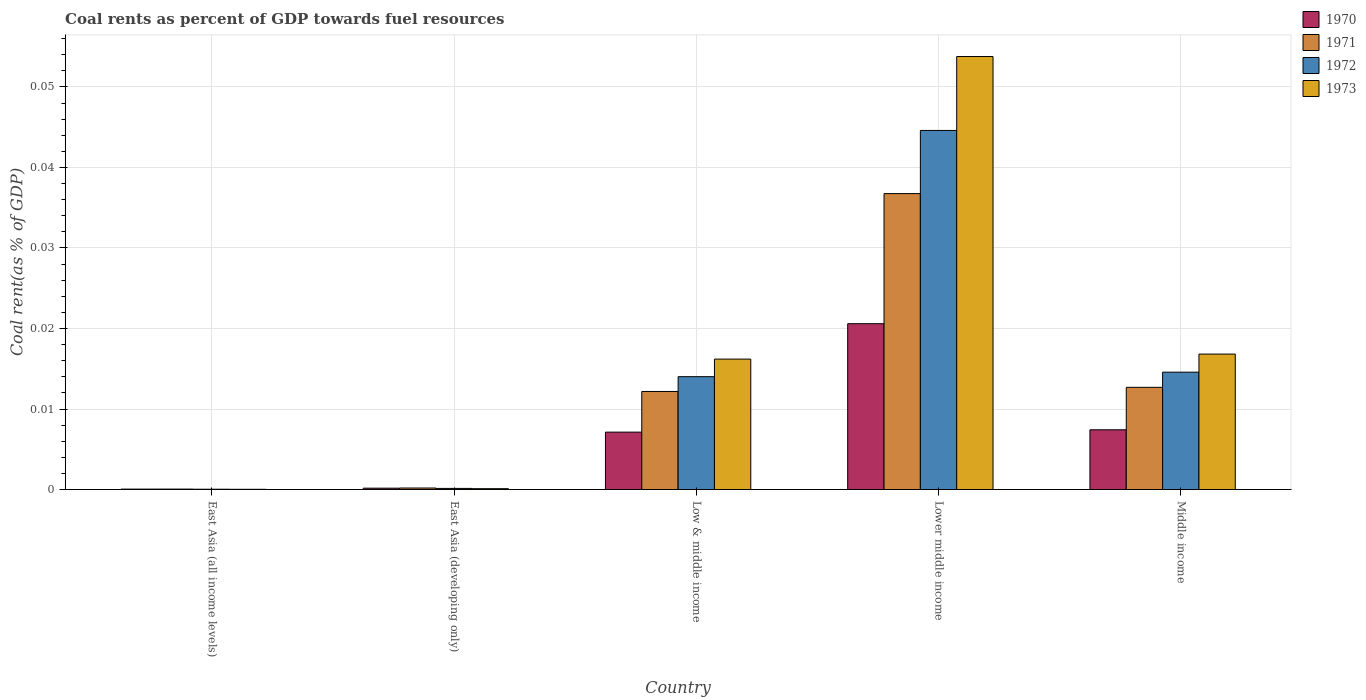Are the number of bars per tick equal to the number of legend labels?
Provide a succinct answer. Yes. Are the number of bars on each tick of the X-axis equal?
Offer a very short reply. Yes. What is the label of the 3rd group of bars from the left?
Provide a succinct answer. Low & middle income. What is the coal rent in 1973 in Middle income?
Provide a short and direct response. 0.02. Across all countries, what is the maximum coal rent in 1970?
Your response must be concise. 0.02. Across all countries, what is the minimum coal rent in 1972?
Give a very brief answer. 3.67730514806032e-5. In which country was the coal rent in 1970 maximum?
Ensure brevity in your answer.  Lower middle income. In which country was the coal rent in 1972 minimum?
Give a very brief answer. East Asia (all income levels). What is the total coal rent in 1973 in the graph?
Give a very brief answer. 0.09. What is the difference between the coal rent in 1973 in East Asia (all income levels) and that in Lower middle income?
Your answer should be very brief. -0.05. What is the difference between the coal rent in 1970 in Low & middle income and the coal rent in 1971 in East Asia (developing only)?
Offer a very short reply. 0.01. What is the average coal rent in 1972 per country?
Provide a short and direct response. 0.01. What is the difference between the coal rent of/in 1970 and coal rent of/in 1973 in Lower middle income?
Provide a succinct answer. -0.03. In how many countries, is the coal rent in 1971 greater than 0.05 %?
Ensure brevity in your answer.  0. What is the ratio of the coal rent in 1973 in Low & middle income to that in Lower middle income?
Offer a very short reply. 0.3. What is the difference between the highest and the second highest coal rent in 1970?
Offer a very short reply. 0.01. What is the difference between the highest and the lowest coal rent in 1972?
Provide a succinct answer. 0.04. Is the sum of the coal rent in 1970 in East Asia (all income levels) and Low & middle income greater than the maximum coal rent in 1971 across all countries?
Ensure brevity in your answer.  No. Is it the case that in every country, the sum of the coal rent in 1971 and coal rent in 1973 is greater than the sum of coal rent in 1970 and coal rent in 1972?
Your answer should be very brief. No. What does the 3rd bar from the left in Lower middle income represents?
Ensure brevity in your answer.  1972. Are all the bars in the graph horizontal?
Give a very brief answer. No. How many countries are there in the graph?
Keep it short and to the point. 5. Does the graph contain grids?
Your answer should be very brief. Yes. How many legend labels are there?
Make the answer very short. 4. What is the title of the graph?
Make the answer very short. Coal rents as percent of GDP towards fuel resources. What is the label or title of the Y-axis?
Your answer should be very brief. Coal rent(as % of GDP). What is the Coal rent(as % of GDP) of 1970 in East Asia (all income levels)?
Keep it short and to the point. 5.1314079013758e-5. What is the Coal rent(as % of GDP) in 1971 in East Asia (all income levels)?
Your answer should be very brief. 5.470114168356261e-5. What is the Coal rent(as % of GDP) in 1972 in East Asia (all income levels)?
Keep it short and to the point. 3.67730514806032e-5. What is the Coal rent(as % of GDP) in 1973 in East Asia (all income levels)?
Ensure brevity in your answer.  2.64171247686014e-5. What is the Coal rent(as % of GDP) in 1970 in East Asia (developing only)?
Make the answer very short. 0. What is the Coal rent(as % of GDP) in 1971 in East Asia (developing only)?
Offer a very short reply. 0. What is the Coal rent(as % of GDP) of 1972 in East Asia (developing only)?
Ensure brevity in your answer.  0. What is the Coal rent(as % of GDP) in 1973 in East Asia (developing only)?
Your answer should be very brief. 0. What is the Coal rent(as % of GDP) of 1970 in Low & middle income?
Offer a very short reply. 0.01. What is the Coal rent(as % of GDP) of 1971 in Low & middle income?
Offer a very short reply. 0.01. What is the Coal rent(as % of GDP) in 1972 in Low & middle income?
Keep it short and to the point. 0.01. What is the Coal rent(as % of GDP) of 1973 in Low & middle income?
Your answer should be compact. 0.02. What is the Coal rent(as % of GDP) of 1970 in Lower middle income?
Give a very brief answer. 0.02. What is the Coal rent(as % of GDP) of 1971 in Lower middle income?
Give a very brief answer. 0.04. What is the Coal rent(as % of GDP) of 1972 in Lower middle income?
Keep it short and to the point. 0.04. What is the Coal rent(as % of GDP) in 1973 in Lower middle income?
Give a very brief answer. 0.05. What is the Coal rent(as % of GDP) of 1970 in Middle income?
Keep it short and to the point. 0.01. What is the Coal rent(as % of GDP) of 1971 in Middle income?
Your answer should be compact. 0.01. What is the Coal rent(as % of GDP) of 1972 in Middle income?
Your answer should be very brief. 0.01. What is the Coal rent(as % of GDP) of 1973 in Middle income?
Offer a terse response. 0.02. Across all countries, what is the maximum Coal rent(as % of GDP) in 1970?
Offer a terse response. 0.02. Across all countries, what is the maximum Coal rent(as % of GDP) in 1971?
Make the answer very short. 0.04. Across all countries, what is the maximum Coal rent(as % of GDP) of 1972?
Your response must be concise. 0.04. Across all countries, what is the maximum Coal rent(as % of GDP) in 1973?
Provide a succinct answer. 0.05. Across all countries, what is the minimum Coal rent(as % of GDP) in 1970?
Ensure brevity in your answer.  5.1314079013758e-5. Across all countries, what is the minimum Coal rent(as % of GDP) of 1971?
Keep it short and to the point. 5.470114168356261e-5. Across all countries, what is the minimum Coal rent(as % of GDP) of 1972?
Your answer should be compact. 3.67730514806032e-5. Across all countries, what is the minimum Coal rent(as % of GDP) in 1973?
Offer a very short reply. 2.64171247686014e-5. What is the total Coal rent(as % of GDP) in 1970 in the graph?
Ensure brevity in your answer.  0.04. What is the total Coal rent(as % of GDP) in 1971 in the graph?
Give a very brief answer. 0.06. What is the total Coal rent(as % of GDP) of 1972 in the graph?
Offer a very short reply. 0.07. What is the total Coal rent(as % of GDP) of 1973 in the graph?
Your answer should be compact. 0.09. What is the difference between the Coal rent(as % of GDP) in 1970 in East Asia (all income levels) and that in East Asia (developing only)?
Keep it short and to the point. -0. What is the difference between the Coal rent(as % of GDP) of 1971 in East Asia (all income levels) and that in East Asia (developing only)?
Ensure brevity in your answer.  -0. What is the difference between the Coal rent(as % of GDP) of 1972 in East Asia (all income levels) and that in East Asia (developing only)?
Your response must be concise. -0. What is the difference between the Coal rent(as % of GDP) in 1973 in East Asia (all income levels) and that in East Asia (developing only)?
Offer a terse response. -0. What is the difference between the Coal rent(as % of GDP) of 1970 in East Asia (all income levels) and that in Low & middle income?
Keep it short and to the point. -0.01. What is the difference between the Coal rent(as % of GDP) in 1971 in East Asia (all income levels) and that in Low & middle income?
Provide a succinct answer. -0.01. What is the difference between the Coal rent(as % of GDP) in 1972 in East Asia (all income levels) and that in Low & middle income?
Your answer should be compact. -0.01. What is the difference between the Coal rent(as % of GDP) of 1973 in East Asia (all income levels) and that in Low & middle income?
Ensure brevity in your answer.  -0.02. What is the difference between the Coal rent(as % of GDP) of 1970 in East Asia (all income levels) and that in Lower middle income?
Your answer should be very brief. -0.02. What is the difference between the Coal rent(as % of GDP) of 1971 in East Asia (all income levels) and that in Lower middle income?
Provide a succinct answer. -0.04. What is the difference between the Coal rent(as % of GDP) in 1972 in East Asia (all income levels) and that in Lower middle income?
Give a very brief answer. -0.04. What is the difference between the Coal rent(as % of GDP) of 1973 in East Asia (all income levels) and that in Lower middle income?
Your response must be concise. -0.05. What is the difference between the Coal rent(as % of GDP) in 1970 in East Asia (all income levels) and that in Middle income?
Provide a succinct answer. -0.01. What is the difference between the Coal rent(as % of GDP) in 1971 in East Asia (all income levels) and that in Middle income?
Ensure brevity in your answer.  -0.01. What is the difference between the Coal rent(as % of GDP) of 1972 in East Asia (all income levels) and that in Middle income?
Keep it short and to the point. -0.01. What is the difference between the Coal rent(as % of GDP) of 1973 in East Asia (all income levels) and that in Middle income?
Provide a succinct answer. -0.02. What is the difference between the Coal rent(as % of GDP) of 1970 in East Asia (developing only) and that in Low & middle income?
Keep it short and to the point. -0.01. What is the difference between the Coal rent(as % of GDP) of 1971 in East Asia (developing only) and that in Low & middle income?
Keep it short and to the point. -0.01. What is the difference between the Coal rent(as % of GDP) of 1972 in East Asia (developing only) and that in Low & middle income?
Offer a terse response. -0.01. What is the difference between the Coal rent(as % of GDP) of 1973 in East Asia (developing only) and that in Low & middle income?
Your answer should be very brief. -0.02. What is the difference between the Coal rent(as % of GDP) in 1970 in East Asia (developing only) and that in Lower middle income?
Your answer should be compact. -0.02. What is the difference between the Coal rent(as % of GDP) in 1971 in East Asia (developing only) and that in Lower middle income?
Ensure brevity in your answer.  -0.04. What is the difference between the Coal rent(as % of GDP) of 1972 in East Asia (developing only) and that in Lower middle income?
Offer a terse response. -0.04. What is the difference between the Coal rent(as % of GDP) of 1973 in East Asia (developing only) and that in Lower middle income?
Your response must be concise. -0.05. What is the difference between the Coal rent(as % of GDP) in 1970 in East Asia (developing only) and that in Middle income?
Your answer should be compact. -0.01. What is the difference between the Coal rent(as % of GDP) of 1971 in East Asia (developing only) and that in Middle income?
Your answer should be very brief. -0.01. What is the difference between the Coal rent(as % of GDP) of 1972 in East Asia (developing only) and that in Middle income?
Offer a very short reply. -0.01. What is the difference between the Coal rent(as % of GDP) in 1973 in East Asia (developing only) and that in Middle income?
Offer a terse response. -0.02. What is the difference between the Coal rent(as % of GDP) of 1970 in Low & middle income and that in Lower middle income?
Provide a succinct answer. -0.01. What is the difference between the Coal rent(as % of GDP) in 1971 in Low & middle income and that in Lower middle income?
Provide a short and direct response. -0.02. What is the difference between the Coal rent(as % of GDP) of 1972 in Low & middle income and that in Lower middle income?
Make the answer very short. -0.03. What is the difference between the Coal rent(as % of GDP) in 1973 in Low & middle income and that in Lower middle income?
Give a very brief answer. -0.04. What is the difference between the Coal rent(as % of GDP) of 1970 in Low & middle income and that in Middle income?
Offer a very short reply. -0. What is the difference between the Coal rent(as % of GDP) of 1971 in Low & middle income and that in Middle income?
Ensure brevity in your answer.  -0. What is the difference between the Coal rent(as % of GDP) of 1972 in Low & middle income and that in Middle income?
Give a very brief answer. -0. What is the difference between the Coal rent(as % of GDP) of 1973 in Low & middle income and that in Middle income?
Your answer should be very brief. -0. What is the difference between the Coal rent(as % of GDP) of 1970 in Lower middle income and that in Middle income?
Your answer should be very brief. 0.01. What is the difference between the Coal rent(as % of GDP) in 1971 in Lower middle income and that in Middle income?
Provide a succinct answer. 0.02. What is the difference between the Coal rent(as % of GDP) of 1973 in Lower middle income and that in Middle income?
Provide a succinct answer. 0.04. What is the difference between the Coal rent(as % of GDP) in 1970 in East Asia (all income levels) and the Coal rent(as % of GDP) in 1971 in East Asia (developing only)?
Your answer should be very brief. -0. What is the difference between the Coal rent(as % of GDP) in 1970 in East Asia (all income levels) and the Coal rent(as % of GDP) in 1972 in East Asia (developing only)?
Ensure brevity in your answer.  -0. What is the difference between the Coal rent(as % of GDP) of 1970 in East Asia (all income levels) and the Coal rent(as % of GDP) of 1973 in East Asia (developing only)?
Your response must be concise. -0. What is the difference between the Coal rent(as % of GDP) of 1971 in East Asia (all income levels) and the Coal rent(as % of GDP) of 1972 in East Asia (developing only)?
Offer a very short reply. -0. What is the difference between the Coal rent(as % of GDP) in 1971 in East Asia (all income levels) and the Coal rent(as % of GDP) in 1973 in East Asia (developing only)?
Provide a succinct answer. -0. What is the difference between the Coal rent(as % of GDP) in 1972 in East Asia (all income levels) and the Coal rent(as % of GDP) in 1973 in East Asia (developing only)?
Ensure brevity in your answer.  -0. What is the difference between the Coal rent(as % of GDP) in 1970 in East Asia (all income levels) and the Coal rent(as % of GDP) in 1971 in Low & middle income?
Your response must be concise. -0.01. What is the difference between the Coal rent(as % of GDP) in 1970 in East Asia (all income levels) and the Coal rent(as % of GDP) in 1972 in Low & middle income?
Your answer should be very brief. -0.01. What is the difference between the Coal rent(as % of GDP) in 1970 in East Asia (all income levels) and the Coal rent(as % of GDP) in 1973 in Low & middle income?
Give a very brief answer. -0.02. What is the difference between the Coal rent(as % of GDP) in 1971 in East Asia (all income levels) and the Coal rent(as % of GDP) in 1972 in Low & middle income?
Your answer should be compact. -0.01. What is the difference between the Coal rent(as % of GDP) in 1971 in East Asia (all income levels) and the Coal rent(as % of GDP) in 1973 in Low & middle income?
Make the answer very short. -0.02. What is the difference between the Coal rent(as % of GDP) in 1972 in East Asia (all income levels) and the Coal rent(as % of GDP) in 1973 in Low & middle income?
Your answer should be very brief. -0.02. What is the difference between the Coal rent(as % of GDP) of 1970 in East Asia (all income levels) and the Coal rent(as % of GDP) of 1971 in Lower middle income?
Provide a succinct answer. -0.04. What is the difference between the Coal rent(as % of GDP) in 1970 in East Asia (all income levels) and the Coal rent(as % of GDP) in 1972 in Lower middle income?
Your answer should be compact. -0.04. What is the difference between the Coal rent(as % of GDP) of 1970 in East Asia (all income levels) and the Coal rent(as % of GDP) of 1973 in Lower middle income?
Give a very brief answer. -0.05. What is the difference between the Coal rent(as % of GDP) in 1971 in East Asia (all income levels) and the Coal rent(as % of GDP) in 1972 in Lower middle income?
Your answer should be compact. -0.04. What is the difference between the Coal rent(as % of GDP) in 1971 in East Asia (all income levels) and the Coal rent(as % of GDP) in 1973 in Lower middle income?
Ensure brevity in your answer.  -0.05. What is the difference between the Coal rent(as % of GDP) in 1972 in East Asia (all income levels) and the Coal rent(as % of GDP) in 1973 in Lower middle income?
Provide a short and direct response. -0.05. What is the difference between the Coal rent(as % of GDP) in 1970 in East Asia (all income levels) and the Coal rent(as % of GDP) in 1971 in Middle income?
Your response must be concise. -0.01. What is the difference between the Coal rent(as % of GDP) of 1970 in East Asia (all income levels) and the Coal rent(as % of GDP) of 1972 in Middle income?
Your response must be concise. -0.01. What is the difference between the Coal rent(as % of GDP) in 1970 in East Asia (all income levels) and the Coal rent(as % of GDP) in 1973 in Middle income?
Make the answer very short. -0.02. What is the difference between the Coal rent(as % of GDP) of 1971 in East Asia (all income levels) and the Coal rent(as % of GDP) of 1972 in Middle income?
Give a very brief answer. -0.01. What is the difference between the Coal rent(as % of GDP) in 1971 in East Asia (all income levels) and the Coal rent(as % of GDP) in 1973 in Middle income?
Ensure brevity in your answer.  -0.02. What is the difference between the Coal rent(as % of GDP) of 1972 in East Asia (all income levels) and the Coal rent(as % of GDP) of 1973 in Middle income?
Offer a terse response. -0.02. What is the difference between the Coal rent(as % of GDP) in 1970 in East Asia (developing only) and the Coal rent(as % of GDP) in 1971 in Low & middle income?
Keep it short and to the point. -0.01. What is the difference between the Coal rent(as % of GDP) of 1970 in East Asia (developing only) and the Coal rent(as % of GDP) of 1972 in Low & middle income?
Offer a terse response. -0.01. What is the difference between the Coal rent(as % of GDP) of 1970 in East Asia (developing only) and the Coal rent(as % of GDP) of 1973 in Low & middle income?
Provide a succinct answer. -0.02. What is the difference between the Coal rent(as % of GDP) of 1971 in East Asia (developing only) and the Coal rent(as % of GDP) of 1972 in Low & middle income?
Your answer should be compact. -0.01. What is the difference between the Coal rent(as % of GDP) of 1971 in East Asia (developing only) and the Coal rent(as % of GDP) of 1973 in Low & middle income?
Keep it short and to the point. -0.02. What is the difference between the Coal rent(as % of GDP) in 1972 in East Asia (developing only) and the Coal rent(as % of GDP) in 1973 in Low & middle income?
Provide a succinct answer. -0.02. What is the difference between the Coal rent(as % of GDP) in 1970 in East Asia (developing only) and the Coal rent(as % of GDP) in 1971 in Lower middle income?
Your answer should be very brief. -0.04. What is the difference between the Coal rent(as % of GDP) in 1970 in East Asia (developing only) and the Coal rent(as % of GDP) in 1972 in Lower middle income?
Provide a succinct answer. -0.04. What is the difference between the Coal rent(as % of GDP) of 1970 in East Asia (developing only) and the Coal rent(as % of GDP) of 1973 in Lower middle income?
Offer a very short reply. -0.05. What is the difference between the Coal rent(as % of GDP) of 1971 in East Asia (developing only) and the Coal rent(as % of GDP) of 1972 in Lower middle income?
Ensure brevity in your answer.  -0.04. What is the difference between the Coal rent(as % of GDP) in 1971 in East Asia (developing only) and the Coal rent(as % of GDP) in 1973 in Lower middle income?
Offer a very short reply. -0.05. What is the difference between the Coal rent(as % of GDP) in 1972 in East Asia (developing only) and the Coal rent(as % of GDP) in 1973 in Lower middle income?
Provide a short and direct response. -0.05. What is the difference between the Coal rent(as % of GDP) of 1970 in East Asia (developing only) and the Coal rent(as % of GDP) of 1971 in Middle income?
Provide a succinct answer. -0.01. What is the difference between the Coal rent(as % of GDP) of 1970 in East Asia (developing only) and the Coal rent(as % of GDP) of 1972 in Middle income?
Give a very brief answer. -0.01. What is the difference between the Coal rent(as % of GDP) in 1970 in East Asia (developing only) and the Coal rent(as % of GDP) in 1973 in Middle income?
Your answer should be very brief. -0.02. What is the difference between the Coal rent(as % of GDP) in 1971 in East Asia (developing only) and the Coal rent(as % of GDP) in 1972 in Middle income?
Offer a very short reply. -0.01. What is the difference between the Coal rent(as % of GDP) in 1971 in East Asia (developing only) and the Coal rent(as % of GDP) in 1973 in Middle income?
Offer a terse response. -0.02. What is the difference between the Coal rent(as % of GDP) of 1972 in East Asia (developing only) and the Coal rent(as % of GDP) of 1973 in Middle income?
Make the answer very short. -0.02. What is the difference between the Coal rent(as % of GDP) of 1970 in Low & middle income and the Coal rent(as % of GDP) of 1971 in Lower middle income?
Offer a terse response. -0.03. What is the difference between the Coal rent(as % of GDP) in 1970 in Low & middle income and the Coal rent(as % of GDP) in 1972 in Lower middle income?
Provide a short and direct response. -0.04. What is the difference between the Coal rent(as % of GDP) in 1970 in Low & middle income and the Coal rent(as % of GDP) in 1973 in Lower middle income?
Your response must be concise. -0.05. What is the difference between the Coal rent(as % of GDP) in 1971 in Low & middle income and the Coal rent(as % of GDP) in 1972 in Lower middle income?
Offer a terse response. -0.03. What is the difference between the Coal rent(as % of GDP) in 1971 in Low & middle income and the Coal rent(as % of GDP) in 1973 in Lower middle income?
Your response must be concise. -0.04. What is the difference between the Coal rent(as % of GDP) in 1972 in Low & middle income and the Coal rent(as % of GDP) in 1973 in Lower middle income?
Give a very brief answer. -0.04. What is the difference between the Coal rent(as % of GDP) in 1970 in Low & middle income and the Coal rent(as % of GDP) in 1971 in Middle income?
Ensure brevity in your answer.  -0.01. What is the difference between the Coal rent(as % of GDP) in 1970 in Low & middle income and the Coal rent(as % of GDP) in 1972 in Middle income?
Your answer should be very brief. -0.01. What is the difference between the Coal rent(as % of GDP) in 1970 in Low & middle income and the Coal rent(as % of GDP) in 1973 in Middle income?
Offer a terse response. -0.01. What is the difference between the Coal rent(as % of GDP) of 1971 in Low & middle income and the Coal rent(as % of GDP) of 1972 in Middle income?
Keep it short and to the point. -0. What is the difference between the Coal rent(as % of GDP) of 1971 in Low & middle income and the Coal rent(as % of GDP) of 1973 in Middle income?
Your answer should be compact. -0. What is the difference between the Coal rent(as % of GDP) of 1972 in Low & middle income and the Coal rent(as % of GDP) of 1973 in Middle income?
Give a very brief answer. -0. What is the difference between the Coal rent(as % of GDP) in 1970 in Lower middle income and the Coal rent(as % of GDP) in 1971 in Middle income?
Your response must be concise. 0.01. What is the difference between the Coal rent(as % of GDP) of 1970 in Lower middle income and the Coal rent(as % of GDP) of 1972 in Middle income?
Keep it short and to the point. 0.01. What is the difference between the Coal rent(as % of GDP) of 1970 in Lower middle income and the Coal rent(as % of GDP) of 1973 in Middle income?
Offer a very short reply. 0. What is the difference between the Coal rent(as % of GDP) of 1971 in Lower middle income and the Coal rent(as % of GDP) of 1972 in Middle income?
Provide a succinct answer. 0.02. What is the difference between the Coal rent(as % of GDP) in 1971 in Lower middle income and the Coal rent(as % of GDP) in 1973 in Middle income?
Provide a short and direct response. 0.02. What is the difference between the Coal rent(as % of GDP) in 1972 in Lower middle income and the Coal rent(as % of GDP) in 1973 in Middle income?
Offer a very short reply. 0.03. What is the average Coal rent(as % of GDP) in 1970 per country?
Your response must be concise. 0.01. What is the average Coal rent(as % of GDP) of 1971 per country?
Offer a terse response. 0.01. What is the average Coal rent(as % of GDP) in 1972 per country?
Offer a terse response. 0.01. What is the average Coal rent(as % of GDP) of 1973 per country?
Keep it short and to the point. 0.02. What is the difference between the Coal rent(as % of GDP) of 1970 and Coal rent(as % of GDP) of 1971 in East Asia (all income levels)?
Provide a succinct answer. -0. What is the difference between the Coal rent(as % of GDP) in 1970 and Coal rent(as % of GDP) in 1972 in East Asia (all income levels)?
Your response must be concise. 0. What is the difference between the Coal rent(as % of GDP) in 1970 and Coal rent(as % of GDP) in 1973 in East Asia (all income levels)?
Give a very brief answer. 0. What is the difference between the Coal rent(as % of GDP) in 1971 and Coal rent(as % of GDP) in 1972 in East Asia (all income levels)?
Provide a succinct answer. 0. What is the difference between the Coal rent(as % of GDP) in 1971 and Coal rent(as % of GDP) in 1973 in East Asia (all income levels)?
Give a very brief answer. 0. What is the difference between the Coal rent(as % of GDP) of 1970 and Coal rent(as % of GDP) of 1972 in East Asia (developing only)?
Your answer should be very brief. 0. What is the difference between the Coal rent(as % of GDP) of 1970 and Coal rent(as % of GDP) of 1973 in East Asia (developing only)?
Offer a very short reply. 0. What is the difference between the Coal rent(as % of GDP) in 1970 and Coal rent(as % of GDP) in 1971 in Low & middle income?
Ensure brevity in your answer.  -0.01. What is the difference between the Coal rent(as % of GDP) in 1970 and Coal rent(as % of GDP) in 1972 in Low & middle income?
Your response must be concise. -0.01. What is the difference between the Coal rent(as % of GDP) in 1970 and Coal rent(as % of GDP) in 1973 in Low & middle income?
Provide a succinct answer. -0.01. What is the difference between the Coal rent(as % of GDP) of 1971 and Coal rent(as % of GDP) of 1972 in Low & middle income?
Your answer should be compact. -0. What is the difference between the Coal rent(as % of GDP) in 1971 and Coal rent(as % of GDP) in 1973 in Low & middle income?
Your response must be concise. -0. What is the difference between the Coal rent(as % of GDP) of 1972 and Coal rent(as % of GDP) of 1973 in Low & middle income?
Your answer should be compact. -0. What is the difference between the Coal rent(as % of GDP) in 1970 and Coal rent(as % of GDP) in 1971 in Lower middle income?
Offer a very short reply. -0.02. What is the difference between the Coal rent(as % of GDP) in 1970 and Coal rent(as % of GDP) in 1972 in Lower middle income?
Your answer should be compact. -0.02. What is the difference between the Coal rent(as % of GDP) of 1970 and Coal rent(as % of GDP) of 1973 in Lower middle income?
Your response must be concise. -0.03. What is the difference between the Coal rent(as % of GDP) of 1971 and Coal rent(as % of GDP) of 1972 in Lower middle income?
Make the answer very short. -0.01. What is the difference between the Coal rent(as % of GDP) in 1971 and Coal rent(as % of GDP) in 1973 in Lower middle income?
Ensure brevity in your answer.  -0.02. What is the difference between the Coal rent(as % of GDP) of 1972 and Coal rent(as % of GDP) of 1973 in Lower middle income?
Your response must be concise. -0.01. What is the difference between the Coal rent(as % of GDP) of 1970 and Coal rent(as % of GDP) of 1971 in Middle income?
Provide a succinct answer. -0.01. What is the difference between the Coal rent(as % of GDP) in 1970 and Coal rent(as % of GDP) in 1972 in Middle income?
Make the answer very short. -0.01. What is the difference between the Coal rent(as % of GDP) of 1970 and Coal rent(as % of GDP) of 1973 in Middle income?
Provide a short and direct response. -0.01. What is the difference between the Coal rent(as % of GDP) of 1971 and Coal rent(as % of GDP) of 1972 in Middle income?
Keep it short and to the point. -0. What is the difference between the Coal rent(as % of GDP) of 1971 and Coal rent(as % of GDP) of 1973 in Middle income?
Provide a short and direct response. -0. What is the difference between the Coal rent(as % of GDP) of 1972 and Coal rent(as % of GDP) of 1973 in Middle income?
Provide a succinct answer. -0. What is the ratio of the Coal rent(as % of GDP) in 1970 in East Asia (all income levels) to that in East Asia (developing only)?
Your answer should be very brief. 0.31. What is the ratio of the Coal rent(as % of GDP) of 1971 in East Asia (all income levels) to that in East Asia (developing only)?
Ensure brevity in your answer.  0.29. What is the ratio of the Coal rent(as % of GDP) of 1972 in East Asia (all income levels) to that in East Asia (developing only)?
Your answer should be compact. 0.27. What is the ratio of the Coal rent(as % of GDP) in 1973 in East Asia (all income levels) to that in East Asia (developing only)?
Offer a terse response. 0.26. What is the ratio of the Coal rent(as % of GDP) of 1970 in East Asia (all income levels) to that in Low & middle income?
Your response must be concise. 0.01. What is the ratio of the Coal rent(as % of GDP) of 1971 in East Asia (all income levels) to that in Low & middle income?
Provide a short and direct response. 0. What is the ratio of the Coal rent(as % of GDP) in 1972 in East Asia (all income levels) to that in Low & middle income?
Offer a terse response. 0. What is the ratio of the Coal rent(as % of GDP) in 1973 in East Asia (all income levels) to that in Low & middle income?
Offer a very short reply. 0. What is the ratio of the Coal rent(as % of GDP) in 1970 in East Asia (all income levels) to that in Lower middle income?
Offer a terse response. 0. What is the ratio of the Coal rent(as % of GDP) in 1971 in East Asia (all income levels) to that in Lower middle income?
Offer a terse response. 0. What is the ratio of the Coal rent(as % of GDP) in 1972 in East Asia (all income levels) to that in Lower middle income?
Offer a very short reply. 0. What is the ratio of the Coal rent(as % of GDP) in 1973 in East Asia (all income levels) to that in Lower middle income?
Your answer should be compact. 0. What is the ratio of the Coal rent(as % of GDP) of 1970 in East Asia (all income levels) to that in Middle income?
Your response must be concise. 0.01. What is the ratio of the Coal rent(as % of GDP) in 1971 in East Asia (all income levels) to that in Middle income?
Ensure brevity in your answer.  0. What is the ratio of the Coal rent(as % of GDP) of 1972 in East Asia (all income levels) to that in Middle income?
Offer a very short reply. 0. What is the ratio of the Coal rent(as % of GDP) of 1973 in East Asia (all income levels) to that in Middle income?
Offer a terse response. 0. What is the ratio of the Coal rent(as % of GDP) of 1970 in East Asia (developing only) to that in Low & middle income?
Offer a terse response. 0.02. What is the ratio of the Coal rent(as % of GDP) of 1971 in East Asia (developing only) to that in Low & middle income?
Make the answer very short. 0.02. What is the ratio of the Coal rent(as % of GDP) of 1972 in East Asia (developing only) to that in Low & middle income?
Ensure brevity in your answer.  0.01. What is the ratio of the Coal rent(as % of GDP) in 1973 in East Asia (developing only) to that in Low & middle income?
Offer a terse response. 0.01. What is the ratio of the Coal rent(as % of GDP) in 1970 in East Asia (developing only) to that in Lower middle income?
Provide a succinct answer. 0.01. What is the ratio of the Coal rent(as % of GDP) of 1971 in East Asia (developing only) to that in Lower middle income?
Make the answer very short. 0.01. What is the ratio of the Coal rent(as % of GDP) of 1972 in East Asia (developing only) to that in Lower middle income?
Your answer should be very brief. 0. What is the ratio of the Coal rent(as % of GDP) in 1973 in East Asia (developing only) to that in Lower middle income?
Your answer should be very brief. 0. What is the ratio of the Coal rent(as % of GDP) of 1970 in East Asia (developing only) to that in Middle income?
Your answer should be very brief. 0.02. What is the ratio of the Coal rent(as % of GDP) of 1971 in East Asia (developing only) to that in Middle income?
Give a very brief answer. 0.01. What is the ratio of the Coal rent(as % of GDP) of 1972 in East Asia (developing only) to that in Middle income?
Ensure brevity in your answer.  0.01. What is the ratio of the Coal rent(as % of GDP) of 1973 in East Asia (developing only) to that in Middle income?
Offer a terse response. 0.01. What is the ratio of the Coal rent(as % of GDP) of 1970 in Low & middle income to that in Lower middle income?
Keep it short and to the point. 0.35. What is the ratio of the Coal rent(as % of GDP) of 1971 in Low & middle income to that in Lower middle income?
Offer a very short reply. 0.33. What is the ratio of the Coal rent(as % of GDP) in 1972 in Low & middle income to that in Lower middle income?
Give a very brief answer. 0.31. What is the ratio of the Coal rent(as % of GDP) in 1973 in Low & middle income to that in Lower middle income?
Your answer should be compact. 0.3. What is the ratio of the Coal rent(as % of GDP) of 1970 in Low & middle income to that in Middle income?
Provide a short and direct response. 0.96. What is the ratio of the Coal rent(as % of GDP) in 1971 in Low & middle income to that in Middle income?
Provide a succinct answer. 0.96. What is the ratio of the Coal rent(as % of GDP) of 1972 in Low & middle income to that in Middle income?
Give a very brief answer. 0.96. What is the ratio of the Coal rent(as % of GDP) in 1973 in Low & middle income to that in Middle income?
Provide a short and direct response. 0.96. What is the ratio of the Coal rent(as % of GDP) in 1970 in Lower middle income to that in Middle income?
Ensure brevity in your answer.  2.78. What is the ratio of the Coal rent(as % of GDP) in 1971 in Lower middle income to that in Middle income?
Your answer should be compact. 2.9. What is the ratio of the Coal rent(as % of GDP) in 1972 in Lower middle income to that in Middle income?
Offer a very short reply. 3.06. What is the ratio of the Coal rent(as % of GDP) of 1973 in Lower middle income to that in Middle income?
Keep it short and to the point. 3.2. What is the difference between the highest and the second highest Coal rent(as % of GDP) of 1970?
Offer a terse response. 0.01. What is the difference between the highest and the second highest Coal rent(as % of GDP) in 1971?
Make the answer very short. 0.02. What is the difference between the highest and the second highest Coal rent(as % of GDP) of 1973?
Keep it short and to the point. 0.04. What is the difference between the highest and the lowest Coal rent(as % of GDP) of 1970?
Your answer should be very brief. 0.02. What is the difference between the highest and the lowest Coal rent(as % of GDP) of 1971?
Keep it short and to the point. 0.04. What is the difference between the highest and the lowest Coal rent(as % of GDP) of 1972?
Give a very brief answer. 0.04. What is the difference between the highest and the lowest Coal rent(as % of GDP) in 1973?
Make the answer very short. 0.05. 